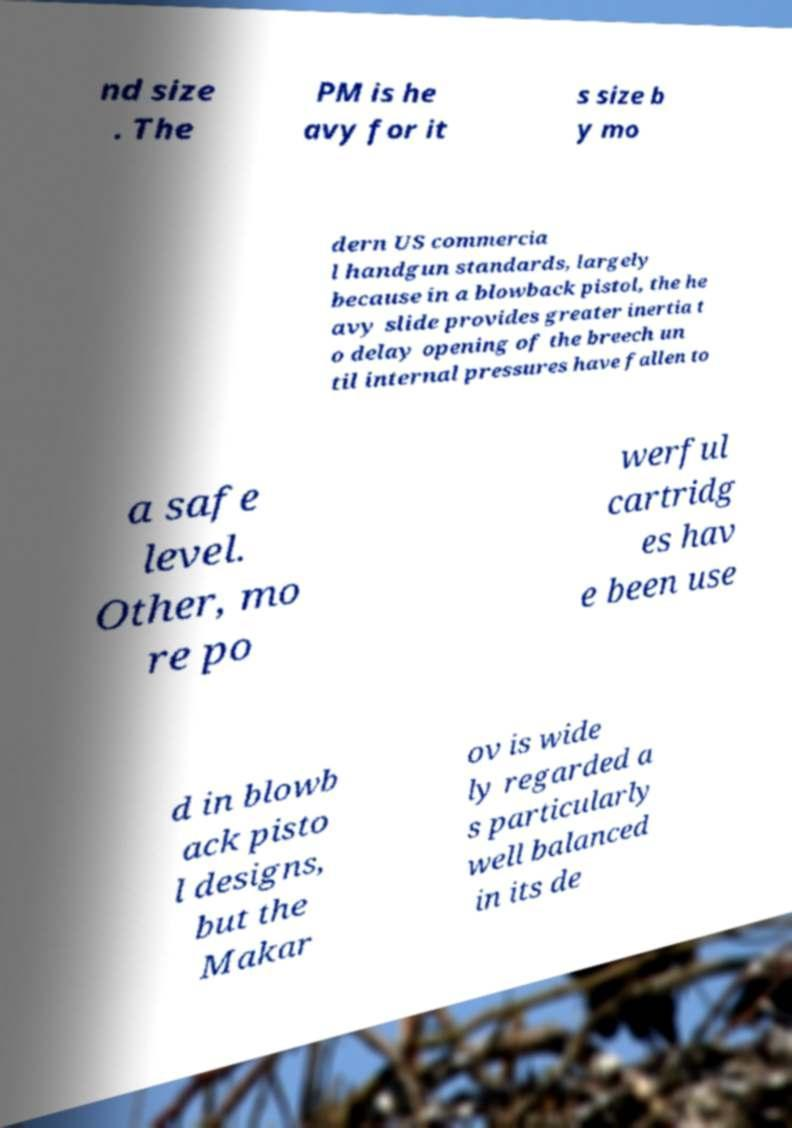Can you accurately transcribe the text from the provided image for me? nd size . The PM is he avy for it s size b y mo dern US commercia l handgun standards, largely because in a blowback pistol, the he avy slide provides greater inertia t o delay opening of the breech un til internal pressures have fallen to a safe level. Other, mo re po werful cartridg es hav e been use d in blowb ack pisto l designs, but the Makar ov is wide ly regarded a s particularly well balanced in its de 